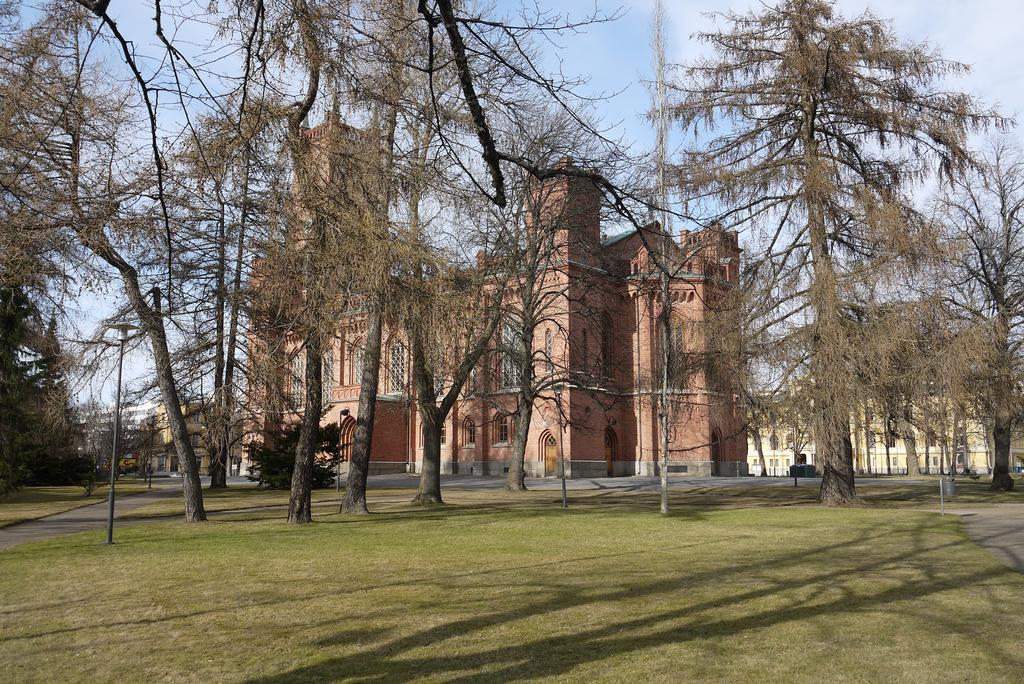What type of structures can be seen in the image? There are buildings in the image. What type of vegetation is present on the ground in the image? Trees and grass are visible on the ground in the image. What type of lighting is present in the image? Pole lights are present in the image. How would you describe the sky in the image? The sky is blue and cloudy in the image. What type of dress is hanging on the tree in the image? There is no dress hanging on the tree in the image; only trees, grass, buildings, pole lights, and a blue, cloudy sky are present. What type of rake is being used to clean the grass in the image? There is no rake present in the image; only trees, grass, buildings, pole lights, and a blue, cloudy sky are visible. 